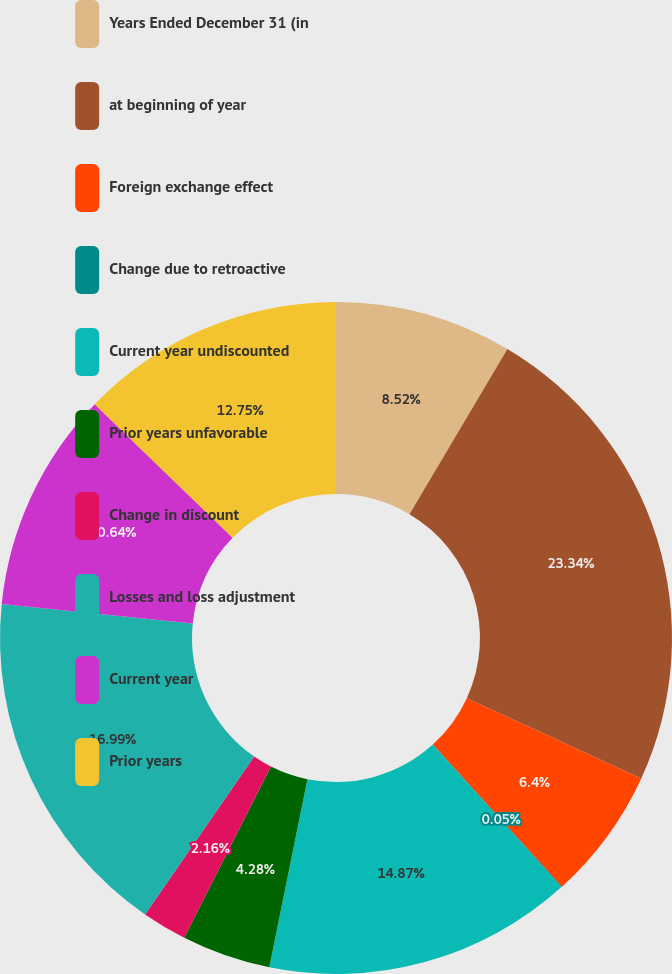Convert chart to OTSL. <chart><loc_0><loc_0><loc_500><loc_500><pie_chart><fcel>Years Ended December 31 (in<fcel>at beginning of year<fcel>Foreign exchange effect<fcel>Change due to retroactive<fcel>Current year undiscounted<fcel>Prior years unfavorable<fcel>Change in discount<fcel>Losses and loss adjustment<fcel>Current year<fcel>Prior years<nl><fcel>8.52%<fcel>23.34%<fcel>6.4%<fcel>0.05%<fcel>14.87%<fcel>4.28%<fcel>2.16%<fcel>16.99%<fcel>10.64%<fcel>12.75%<nl></chart> 